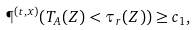Convert formula to latex. <formula><loc_0><loc_0><loc_500><loc_500>\P ^ { ( t , x ) } ( T _ { A } ( Z ) < \tau _ { r } ( Z ) ) \geq c _ { 1 } ,</formula> 